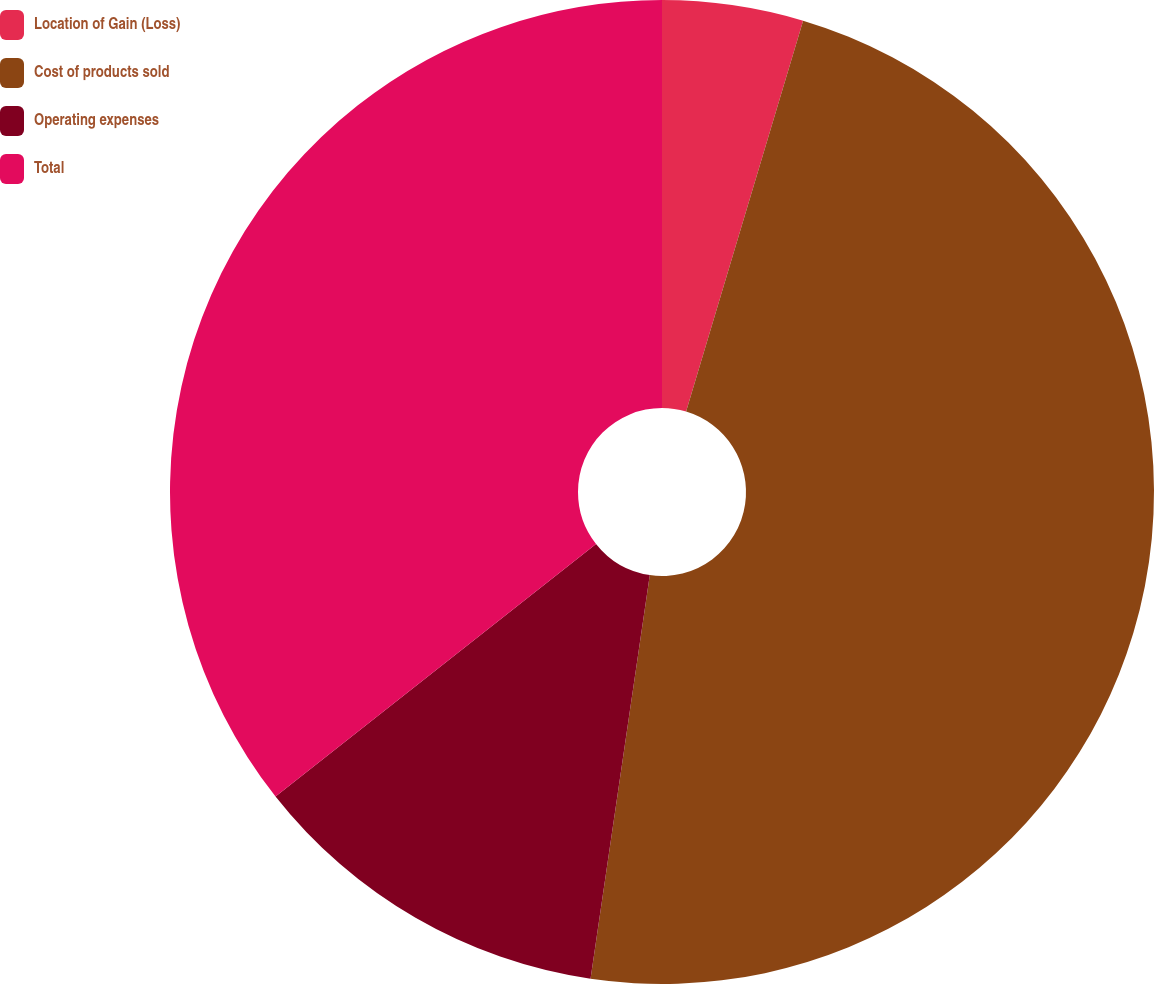<chart> <loc_0><loc_0><loc_500><loc_500><pie_chart><fcel>Location of Gain (Loss)<fcel>Cost of products sold<fcel>Operating expenses<fcel>Total<nl><fcel>4.63%<fcel>47.69%<fcel>12.06%<fcel>35.62%<nl></chart> 